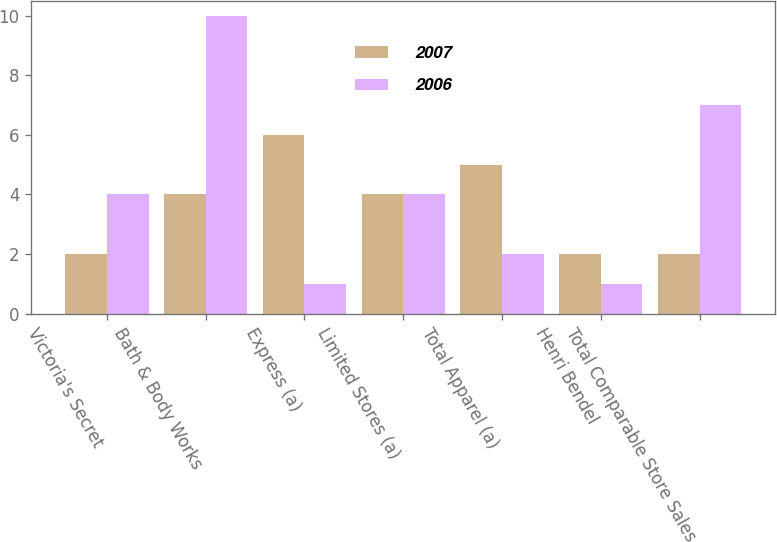Convert chart to OTSL. <chart><loc_0><loc_0><loc_500><loc_500><stacked_bar_chart><ecel><fcel>Victoria's Secret<fcel>Bath & Body Works<fcel>Express (a)<fcel>Limited Stores (a)<fcel>Total Apparel (a)<fcel>Henri Bendel<fcel>Total Comparable Store Sales<nl><fcel>2007<fcel>2<fcel>4<fcel>6<fcel>4<fcel>5<fcel>2<fcel>2<nl><fcel>2006<fcel>4<fcel>10<fcel>1<fcel>4<fcel>2<fcel>1<fcel>7<nl></chart> 